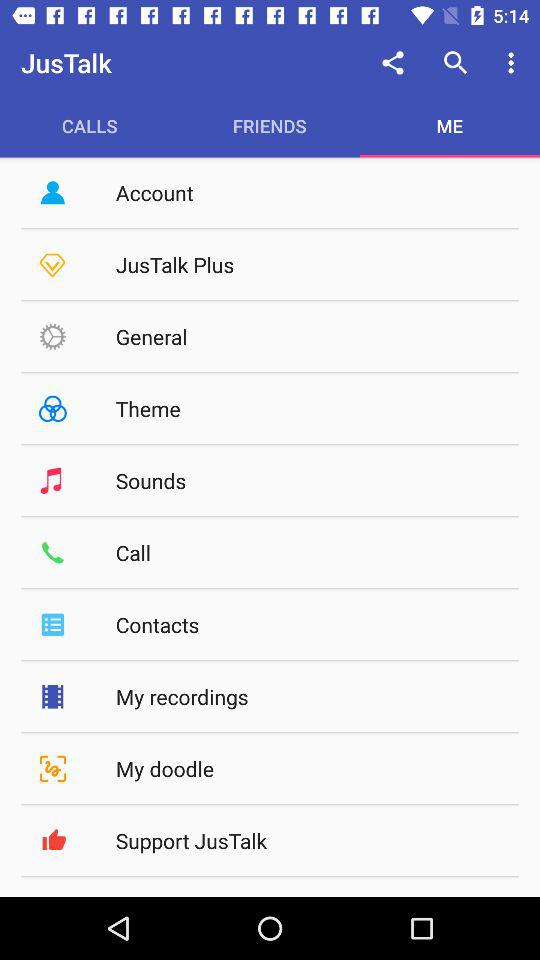How many notifications are there in "Sounds?
When the provided information is insufficient, respond with <no answer>. <no answer> 